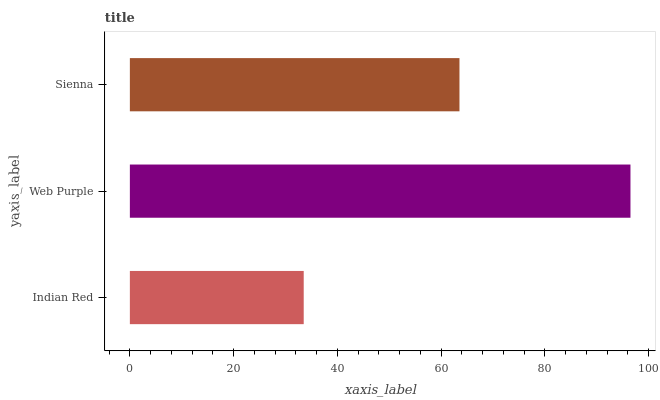Is Indian Red the minimum?
Answer yes or no. Yes. Is Web Purple the maximum?
Answer yes or no. Yes. Is Sienna the minimum?
Answer yes or no. No. Is Sienna the maximum?
Answer yes or no. No. Is Web Purple greater than Sienna?
Answer yes or no. Yes. Is Sienna less than Web Purple?
Answer yes or no. Yes. Is Sienna greater than Web Purple?
Answer yes or no. No. Is Web Purple less than Sienna?
Answer yes or no. No. Is Sienna the high median?
Answer yes or no. Yes. Is Sienna the low median?
Answer yes or no. Yes. Is Indian Red the high median?
Answer yes or no. No. Is Web Purple the low median?
Answer yes or no. No. 